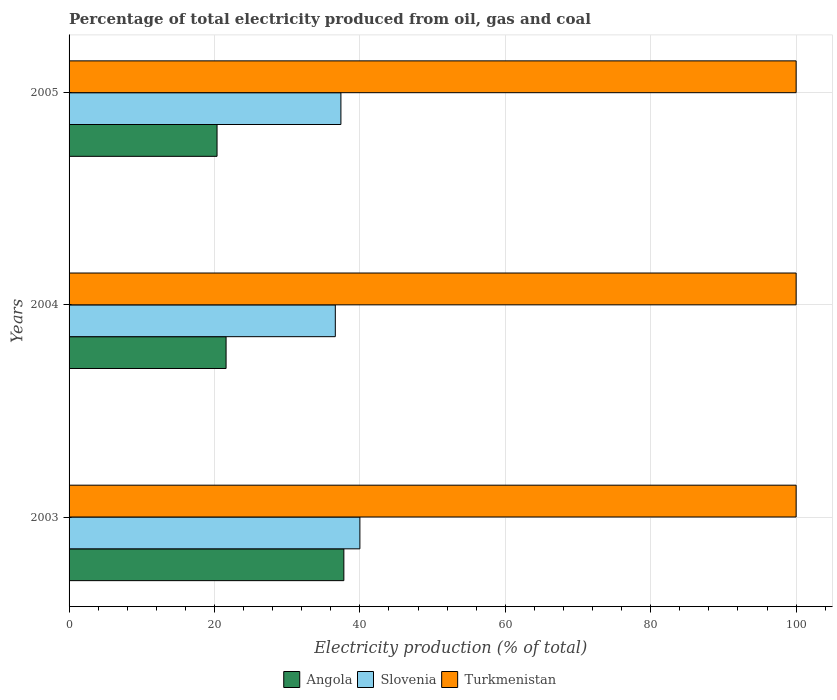Are the number of bars per tick equal to the number of legend labels?
Ensure brevity in your answer.  Yes. Are the number of bars on each tick of the Y-axis equal?
Keep it short and to the point. Yes. How many bars are there on the 1st tick from the top?
Offer a terse response. 3. How many bars are there on the 3rd tick from the bottom?
Your response must be concise. 3. In how many cases, is the number of bars for a given year not equal to the number of legend labels?
Keep it short and to the point. 0. What is the electricity production in in Angola in 2003?
Offer a very short reply. 37.79. Across all years, what is the maximum electricity production in in Angola?
Your answer should be very brief. 37.79. Across all years, what is the minimum electricity production in in Turkmenistan?
Your answer should be compact. 100. In which year was the electricity production in in Turkmenistan maximum?
Provide a succinct answer. 2003. What is the total electricity production in in Angola in the graph?
Ensure brevity in your answer.  79.74. What is the difference between the electricity production in in Angola in 2004 and that in 2005?
Give a very brief answer. 1.24. What is the difference between the electricity production in in Angola in 2004 and the electricity production in in Slovenia in 2005?
Provide a short and direct response. -15.79. What is the average electricity production in in Angola per year?
Ensure brevity in your answer.  26.58. In the year 2005, what is the difference between the electricity production in in Turkmenistan and electricity production in in Angola?
Offer a very short reply. 79.65. In how many years, is the electricity production in in Slovenia greater than 8 %?
Ensure brevity in your answer.  3. What is the ratio of the electricity production in in Slovenia in 2003 to that in 2005?
Ensure brevity in your answer.  1.07. Is the electricity production in in Turkmenistan in 2004 less than that in 2005?
Offer a terse response. No. What is the difference between the highest and the lowest electricity production in in Angola?
Offer a terse response. 17.44. What does the 1st bar from the top in 2004 represents?
Provide a succinct answer. Turkmenistan. What does the 2nd bar from the bottom in 2003 represents?
Provide a succinct answer. Slovenia. How many bars are there?
Offer a terse response. 9. How many years are there in the graph?
Your answer should be very brief. 3. What is the difference between two consecutive major ticks on the X-axis?
Provide a succinct answer. 20. Does the graph contain any zero values?
Make the answer very short. No. How are the legend labels stacked?
Give a very brief answer. Horizontal. What is the title of the graph?
Keep it short and to the point. Percentage of total electricity produced from oil, gas and coal. Does "Central African Republic" appear as one of the legend labels in the graph?
Ensure brevity in your answer.  No. What is the label or title of the X-axis?
Ensure brevity in your answer.  Electricity production (% of total). What is the Electricity production (% of total) of Angola in 2003?
Keep it short and to the point. 37.79. What is the Electricity production (% of total) in Slovenia in 2003?
Give a very brief answer. 40. What is the Electricity production (% of total) of Turkmenistan in 2003?
Your answer should be very brief. 100. What is the Electricity production (% of total) in Angola in 2004?
Offer a very short reply. 21.59. What is the Electricity production (% of total) in Slovenia in 2004?
Your answer should be compact. 36.62. What is the Electricity production (% of total) in Turkmenistan in 2004?
Make the answer very short. 100. What is the Electricity production (% of total) in Angola in 2005?
Provide a short and direct response. 20.35. What is the Electricity production (% of total) in Slovenia in 2005?
Offer a very short reply. 37.39. Across all years, what is the maximum Electricity production (% of total) of Angola?
Provide a short and direct response. 37.79. Across all years, what is the maximum Electricity production (% of total) in Slovenia?
Offer a very short reply. 40. Across all years, what is the minimum Electricity production (% of total) of Angola?
Your answer should be very brief. 20.35. Across all years, what is the minimum Electricity production (% of total) of Slovenia?
Keep it short and to the point. 36.62. What is the total Electricity production (% of total) in Angola in the graph?
Make the answer very short. 79.74. What is the total Electricity production (% of total) of Slovenia in the graph?
Your response must be concise. 114.01. What is the total Electricity production (% of total) of Turkmenistan in the graph?
Ensure brevity in your answer.  300. What is the difference between the Electricity production (% of total) of Angola in 2003 and that in 2004?
Keep it short and to the point. 16.2. What is the difference between the Electricity production (% of total) of Slovenia in 2003 and that in 2004?
Ensure brevity in your answer.  3.38. What is the difference between the Electricity production (% of total) in Angola in 2003 and that in 2005?
Ensure brevity in your answer.  17.44. What is the difference between the Electricity production (% of total) in Slovenia in 2003 and that in 2005?
Your response must be concise. 2.61. What is the difference between the Electricity production (% of total) of Angola in 2004 and that in 2005?
Your answer should be compact. 1.24. What is the difference between the Electricity production (% of total) of Slovenia in 2004 and that in 2005?
Make the answer very short. -0.77. What is the difference between the Electricity production (% of total) of Turkmenistan in 2004 and that in 2005?
Offer a very short reply. 0. What is the difference between the Electricity production (% of total) in Angola in 2003 and the Electricity production (% of total) in Slovenia in 2004?
Offer a terse response. 1.18. What is the difference between the Electricity production (% of total) in Angola in 2003 and the Electricity production (% of total) in Turkmenistan in 2004?
Your answer should be compact. -62.21. What is the difference between the Electricity production (% of total) in Slovenia in 2003 and the Electricity production (% of total) in Turkmenistan in 2004?
Offer a terse response. -60. What is the difference between the Electricity production (% of total) in Angola in 2003 and the Electricity production (% of total) in Slovenia in 2005?
Your answer should be compact. 0.41. What is the difference between the Electricity production (% of total) in Angola in 2003 and the Electricity production (% of total) in Turkmenistan in 2005?
Keep it short and to the point. -62.21. What is the difference between the Electricity production (% of total) of Slovenia in 2003 and the Electricity production (% of total) of Turkmenistan in 2005?
Provide a succinct answer. -60. What is the difference between the Electricity production (% of total) of Angola in 2004 and the Electricity production (% of total) of Slovenia in 2005?
Offer a terse response. -15.79. What is the difference between the Electricity production (% of total) of Angola in 2004 and the Electricity production (% of total) of Turkmenistan in 2005?
Provide a short and direct response. -78.41. What is the difference between the Electricity production (% of total) of Slovenia in 2004 and the Electricity production (% of total) of Turkmenistan in 2005?
Give a very brief answer. -63.38. What is the average Electricity production (% of total) in Angola per year?
Provide a succinct answer. 26.58. What is the average Electricity production (% of total) in Slovenia per year?
Your answer should be compact. 38. In the year 2003, what is the difference between the Electricity production (% of total) in Angola and Electricity production (% of total) in Slovenia?
Provide a succinct answer. -2.21. In the year 2003, what is the difference between the Electricity production (% of total) of Angola and Electricity production (% of total) of Turkmenistan?
Your answer should be very brief. -62.21. In the year 2003, what is the difference between the Electricity production (% of total) of Slovenia and Electricity production (% of total) of Turkmenistan?
Provide a succinct answer. -60. In the year 2004, what is the difference between the Electricity production (% of total) in Angola and Electricity production (% of total) in Slovenia?
Your answer should be compact. -15.02. In the year 2004, what is the difference between the Electricity production (% of total) in Angola and Electricity production (% of total) in Turkmenistan?
Keep it short and to the point. -78.41. In the year 2004, what is the difference between the Electricity production (% of total) in Slovenia and Electricity production (% of total) in Turkmenistan?
Offer a terse response. -63.38. In the year 2005, what is the difference between the Electricity production (% of total) in Angola and Electricity production (% of total) in Slovenia?
Make the answer very short. -17.04. In the year 2005, what is the difference between the Electricity production (% of total) of Angola and Electricity production (% of total) of Turkmenistan?
Provide a succinct answer. -79.65. In the year 2005, what is the difference between the Electricity production (% of total) of Slovenia and Electricity production (% of total) of Turkmenistan?
Keep it short and to the point. -62.61. What is the ratio of the Electricity production (% of total) in Angola in 2003 to that in 2004?
Provide a short and direct response. 1.75. What is the ratio of the Electricity production (% of total) of Slovenia in 2003 to that in 2004?
Provide a short and direct response. 1.09. What is the ratio of the Electricity production (% of total) of Angola in 2003 to that in 2005?
Your answer should be compact. 1.86. What is the ratio of the Electricity production (% of total) of Slovenia in 2003 to that in 2005?
Keep it short and to the point. 1.07. What is the ratio of the Electricity production (% of total) of Angola in 2004 to that in 2005?
Give a very brief answer. 1.06. What is the ratio of the Electricity production (% of total) in Slovenia in 2004 to that in 2005?
Your answer should be very brief. 0.98. What is the difference between the highest and the second highest Electricity production (% of total) in Angola?
Provide a succinct answer. 16.2. What is the difference between the highest and the second highest Electricity production (% of total) in Slovenia?
Provide a succinct answer. 2.61. What is the difference between the highest and the second highest Electricity production (% of total) in Turkmenistan?
Offer a terse response. 0. What is the difference between the highest and the lowest Electricity production (% of total) in Angola?
Provide a succinct answer. 17.44. What is the difference between the highest and the lowest Electricity production (% of total) in Slovenia?
Offer a terse response. 3.38. What is the difference between the highest and the lowest Electricity production (% of total) of Turkmenistan?
Make the answer very short. 0. 